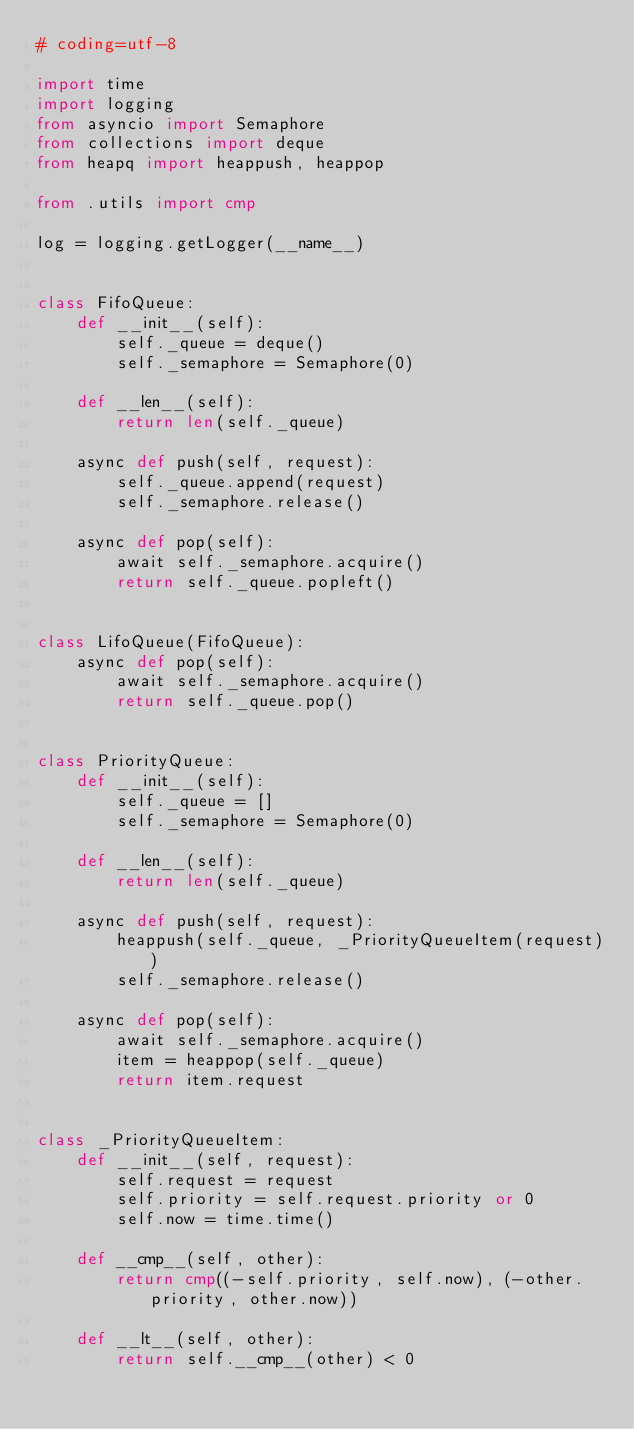<code> <loc_0><loc_0><loc_500><loc_500><_Python_># coding=utf-8

import time
import logging
from asyncio import Semaphore
from collections import deque
from heapq import heappush, heappop

from .utils import cmp

log = logging.getLogger(__name__)


class FifoQueue:
    def __init__(self):
        self._queue = deque()
        self._semaphore = Semaphore(0)

    def __len__(self):
        return len(self._queue)

    async def push(self, request):
        self._queue.append(request)
        self._semaphore.release()

    async def pop(self):
        await self._semaphore.acquire()
        return self._queue.popleft()


class LifoQueue(FifoQueue):
    async def pop(self):
        await self._semaphore.acquire()
        return self._queue.pop()


class PriorityQueue:
    def __init__(self):
        self._queue = []
        self._semaphore = Semaphore(0)

    def __len__(self):
        return len(self._queue)

    async def push(self, request):
        heappush(self._queue, _PriorityQueueItem(request))
        self._semaphore.release()

    async def pop(self):
        await self._semaphore.acquire()
        item = heappop(self._queue)
        return item.request


class _PriorityQueueItem:
    def __init__(self, request):
        self.request = request
        self.priority = self.request.priority or 0
        self.now = time.time()

    def __cmp__(self, other):
        return cmp((-self.priority, self.now), (-other.priority, other.now))

    def __lt__(self, other):
        return self.__cmp__(other) < 0
</code> 